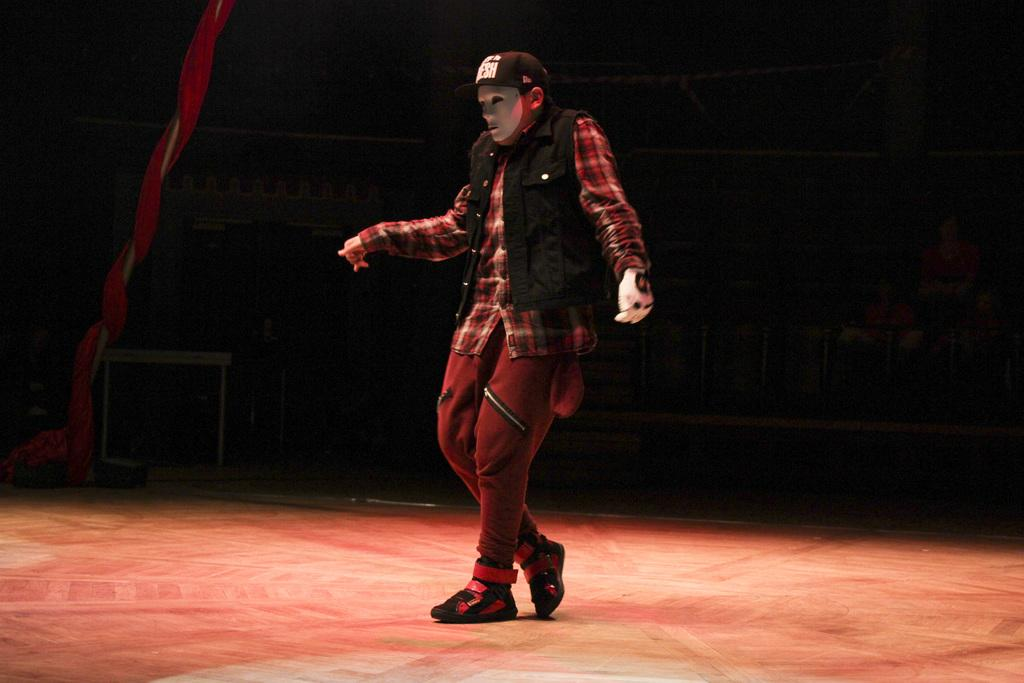What is the main subject of the image? There is a man in the image. What is the man doing in the image? The man is standing in the image. Can you describe the man's attire in the image? The man is wearing a cap, a mask, a glove, and shoes in the image. What is the surface beneath the man's feet in the image? There is a floor in the image. What other object can be seen in the image? There is a cloth visible in the image. How many toes can be seen on the man's feet in the image? The image does not show the man's toes, as he is wearing shoes. What type of bead is being used as a decoration on the man's cap in the image? There is no bead present on the man's cap in the image. 